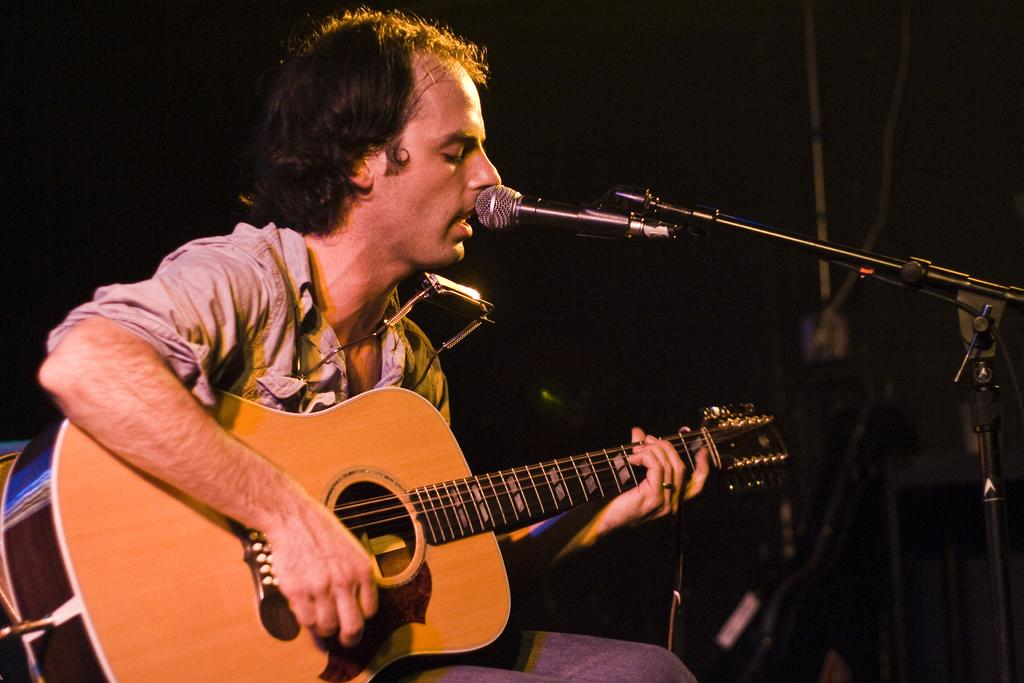Who is the main subject in the image? There is a person in the image. What is the person wearing? The person is wearing a brown color shirt. What is the person doing in the image? The person is playing a guitar. What object is in front of the person? There is a microphone in front of the person. How many beds are visible in the image? There are no beds present in the image. Is there any evidence of a crime in the image? There is no indication of a crime in the image. 